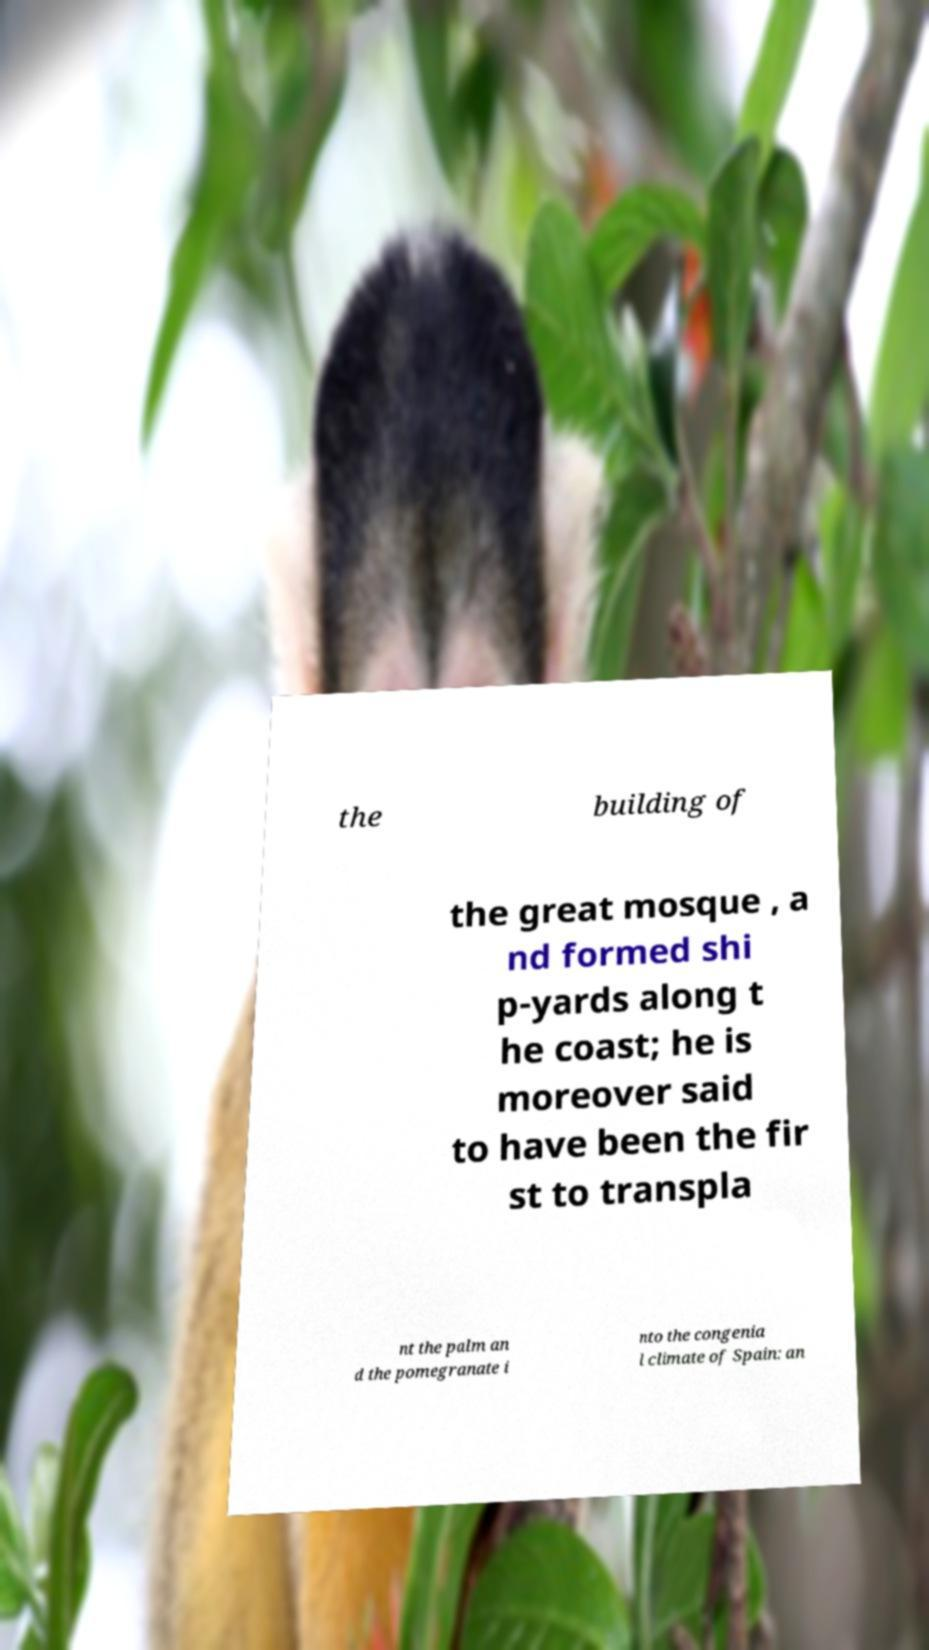Could you assist in decoding the text presented in this image and type it out clearly? the building of the great mosque , a nd formed shi p-yards along t he coast; he is moreover said to have been the fir st to transpla nt the palm an d the pomegranate i nto the congenia l climate of Spain: an 